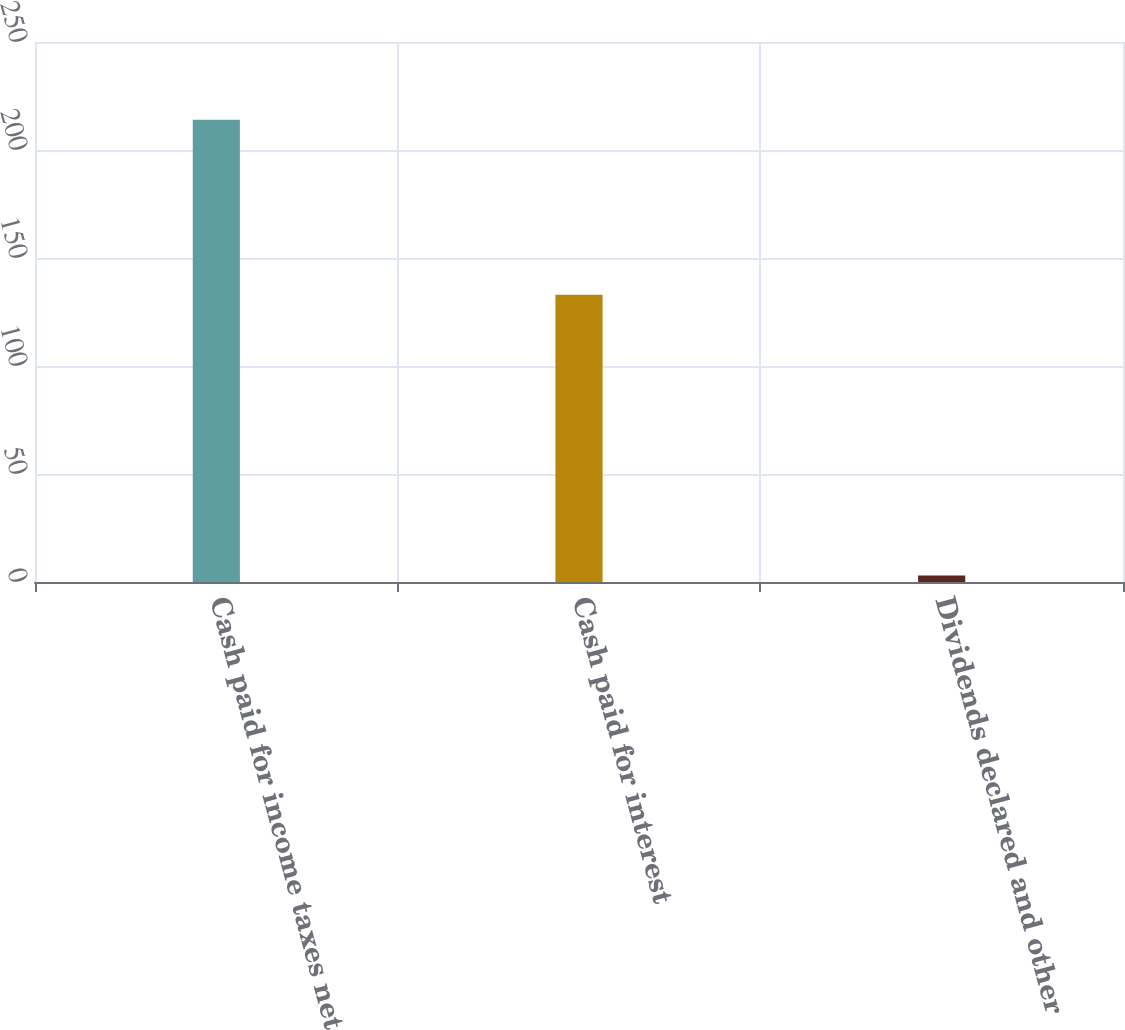<chart> <loc_0><loc_0><loc_500><loc_500><bar_chart><fcel>Cash paid for income taxes net<fcel>Cash paid for interest<fcel>Dividends declared and other<nl><fcel>214<fcel>133<fcel>3<nl></chart> 